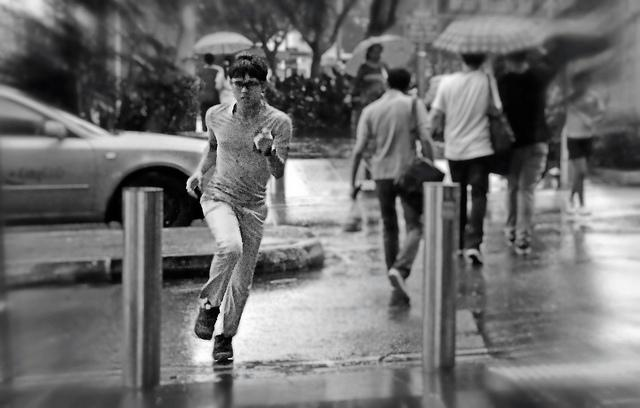What is the boy running through?

Choices:
A) snow
B) rain
C) corn field
D) bar rain 